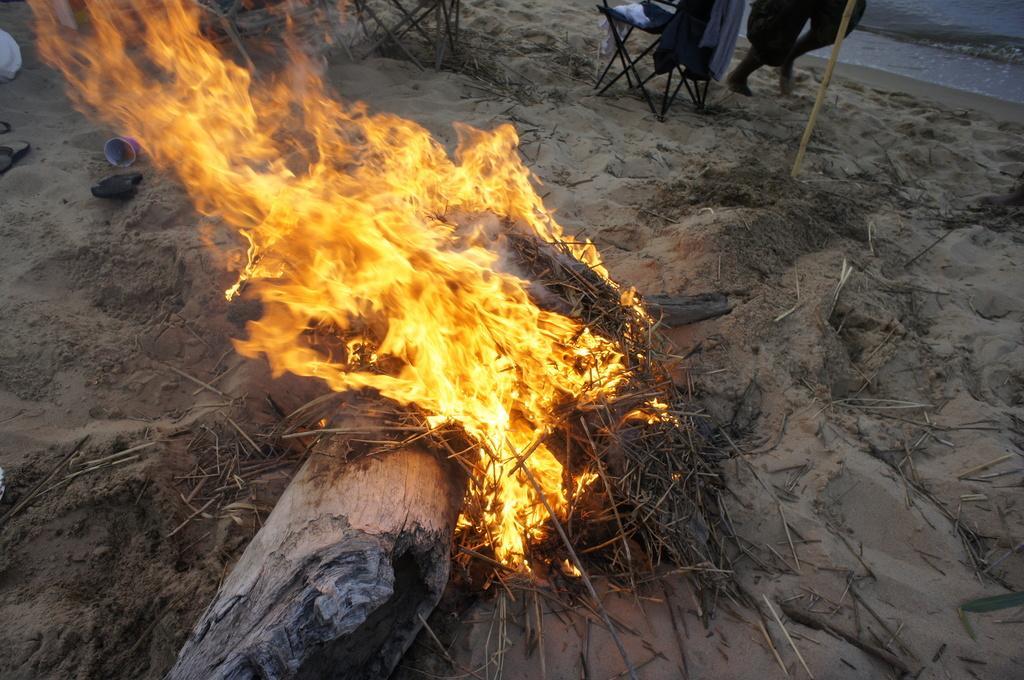Can you describe this image briefly? In this picture I can see a wooden trunk and stems with fire, there are chairs and some other objects on the sand, there are legs of a person and there is water. 